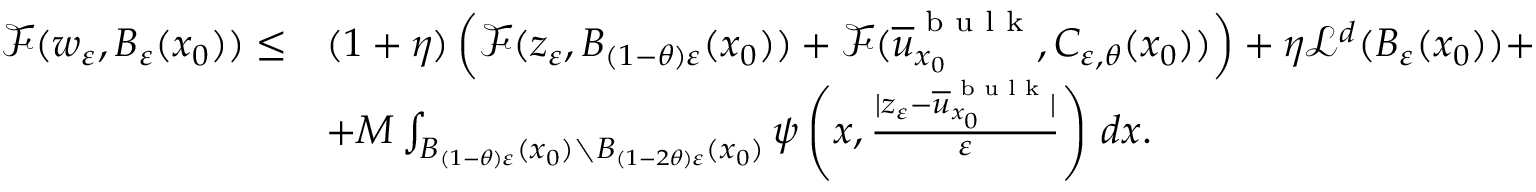Convert formula to latex. <formula><loc_0><loc_0><loc_500><loc_500>\begin{array} { r l } { \mathcal { F } ( w _ { \varepsilon } , B _ { \varepsilon } ( x _ { 0 } ) ) \leq } & { ( 1 + \eta ) \left ( \mathcal { F } ( z _ { \varepsilon } , B _ { ( 1 - \theta ) \varepsilon } ( x _ { 0 } ) ) + \mathcal { F } ( \overline { u } _ { x _ { 0 } } ^ { b u l k } , C _ { \varepsilon , \theta } ( x _ { 0 } ) ) \right ) + \eta \mathcal { L } ^ { d } ( B _ { \varepsilon } ( x _ { 0 } ) ) + } \\ & { + M \int _ { B _ { ( 1 - \theta ) \varepsilon } ( x _ { 0 } ) \ B _ { ( 1 - 2 \theta ) \varepsilon } ( x _ { 0 } ) } \psi \left ( x , \frac { | z _ { \varepsilon } - \overline { u } _ { x _ { 0 } } ^ { b u l k } | } { \varepsilon } \right ) \, d x . } \end{array}</formula> 